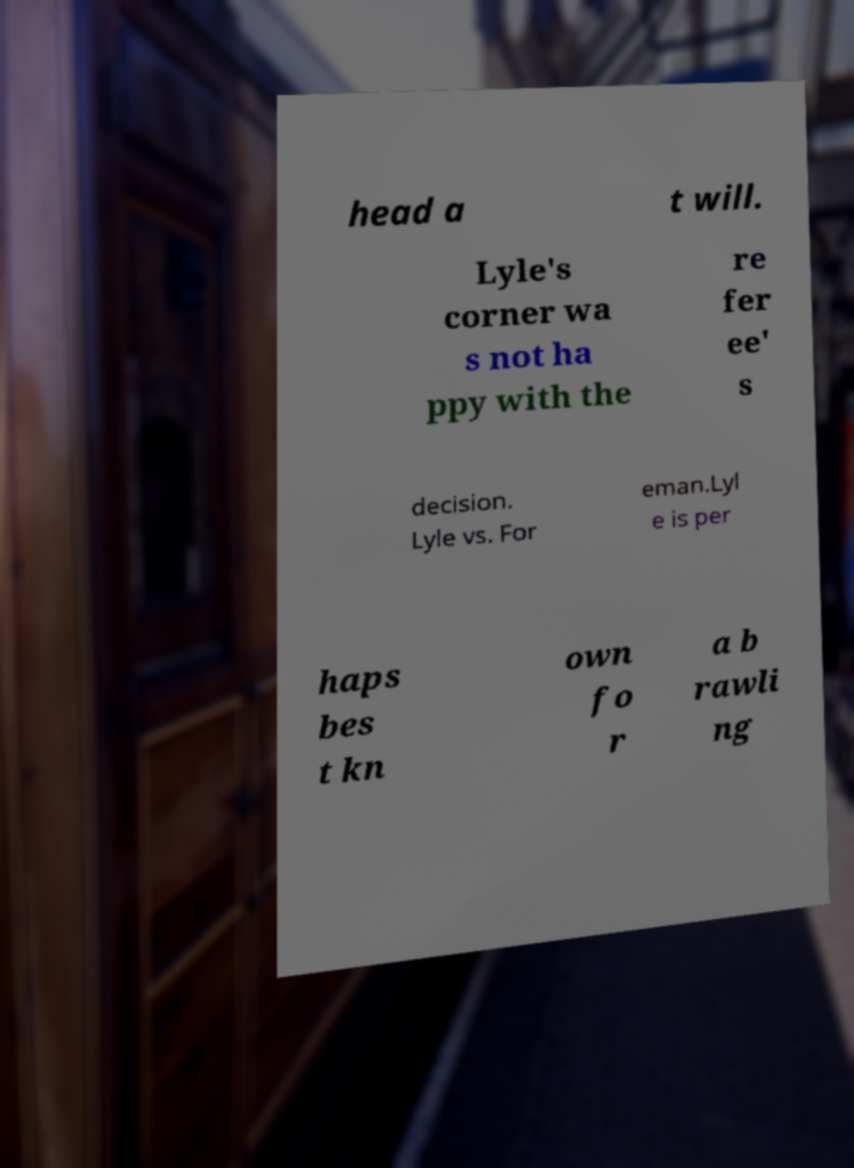There's text embedded in this image that I need extracted. Can you transcribe it verbatim? head a t will. Lyle's corner wa s not ha ppy with the re fer ee' s decision. Lyle vs. For eman.Lyl e is per haps bes t kn own fo r a b rawli ng 